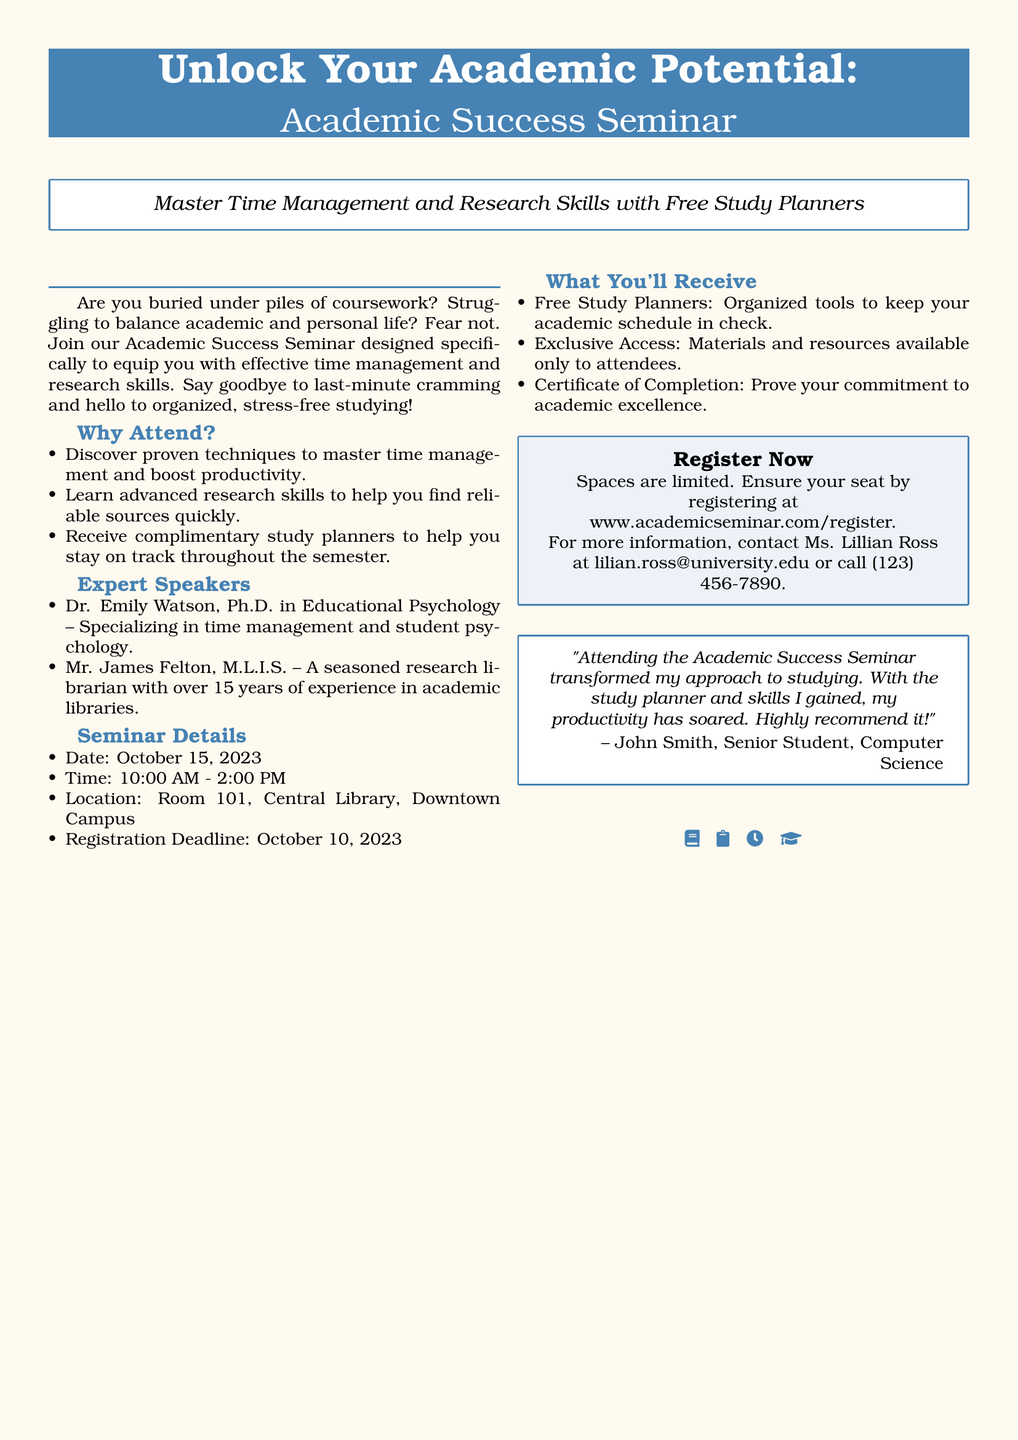What is the date of the seminar? The seminar is scheduled to take place on October 15, 2023.
Answer: October 15, 2023 Who is the speaker with a Ph.D. in Educational Psychology? Dr. Emily Watson holds a Ph.D. in Educational Psychology and specializes in time management and student psychology.
Answer: Dr. Emily Watson What complimentary item will attendees receive? Attendees will receive free study planners to help them stay organized.
Answer: Free Study Planners What is the registration deadline for the seminar? Participants must register for the seminar by October 10, 2023.
Answer: October 10, 2023 What is the time duration of the seminar? The seminar will run from 10:00 AM to 2:00 PM, which is a span of four hours.
Answer: 10:00 AM - 2:00 PM How is the venue for the seminar specified? The location of the seminar is given as Room 101, Central Library, Downtown Campus.
Answer: Room 101, Central Library, Downtown Campus Why should students attend according to the document? Students should attend to discover techniques for time management and advanced research skills.
Answer: To discover techniques for time management and advanced research skills What type of certificate will attendees receive? Attendees will receive a certificate of completion proving their commitment to academic excellence.
Answer: Certificate of Completion 